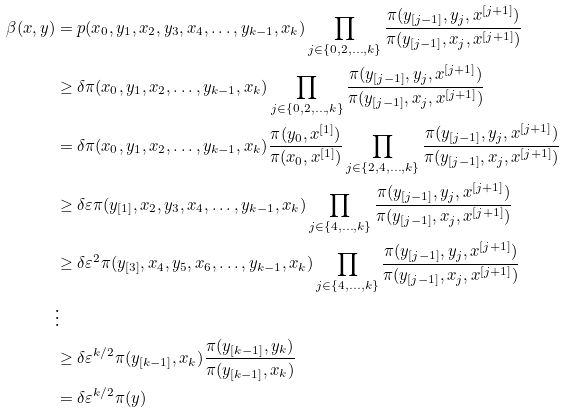Convert formula to latex. <formula><loc_0><loc_0><loc_500><loc_500>\beta ( x , y ) & = p ( x _ { 0 } , y _ { 1 } , x _ { 2 } , y _ { 3 } , x _ { 4 } , \dots , y _ { k - 1 } , x _ { k } ) \prod _ { j \in \left \{ 0 , 2 , \dots , k \right \} } \frac { \pi ( y _ { [ j - 1 ] } , y _ { j } , x ^ { [ j + 1 ] } ) } { \pi ( y _ { [ j - 1 ] } , x _ { j } , x ^ { [ j + 1 ] } ) } \\ & \geq \delta \pi ( x _ { 0 } , y _ { 1 } , x _ { 2 } , \dots , y _ { k - 1 } , x _ { k } ) \prod _ { j \in \left \{ 0 , 2 , \dots , k \right \} } \frac { \pi ( y _ { [ j - 1 ] } , y _ { j } , x ^ { [ j + 1 ] } ) } { \pi ( y _ { [ j - 1 ] } , x _ { j } , x ^ { [ j + 1 ] } ) } \\ & = \delta \pi ( x _ { 0 } , y _ { 1 } , x _ { 2 } , \dots , y _ { k - 1 } , x _ { k } ) \frac { \pi ( y _ { 0 } , x ^ { [ 1 ] } ) } { \pi ( x _ { 0 } , x ^ { [ 1 ] } ) } \prod _ { j \in \left \{ 2 , 4 , \dots , k \right \} } \frac { \pi ( y _ { [ j - 1 ] } , y _ { j } , x ^ { [ j + 1 ] } ) } { \pi ( y _ { [ j - 1 ] } , x _ { j } , x ^ { [ j + 1 ] } ) } \\ & \geq \delta \varepsilon \pi ( y _ { [ 1 ] } , x _ { 2 } , y _ { 3 } , x _ { 4 } , \dots , y _ { k - 1 } , x _ { k } ) \prod _ { j \in \left \{ 4 , \dots , k \right \} } \frac { \pi ( y _ { [ j - 1 ] } , y _ { j } , x ^ { [ j + 1 ] } ) } { \pi ( y _ { [ j - 1 ] } , x _ { j } , x ^ { [ j + 1 ] } ) } \\ & \geq \delta \varepsilon ^ { 2 } \pi ( y _ { [ 3 ] } , x _ { 4 } , y _ { 5 } , x _ { 6 } , \dots , y _ { k - 1 } , x _ { k } ) \prod _ { j \in \left \{ 4 , \dots , k \right \} } \frac { \pi ( y _ { [ j - 1 ] } , y _ { j } , x ^ { [ j + 1 ] } ) } { \pi ( y _ { [ j - 1 ] } , x _ { j } , x ^ { [ j + 1 ] } ) } \\ & \vdots \\ & \geq \delta \varepsilon ^ { k / 2 } \pi ( y _ { [ k - 1 ] } , x _ { k } ) \frac { \pi ( y _ { [ k - 1 ] } , y _ { k } ) } { \pi ( y _ { [ k - 1 ] } , x _ { k } ) } \\ & = \delta \varepsilon ^ { k / 2 } \pi ( y )</formula> 